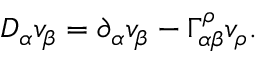<formula> <loc_0><loc_0><loc_500><loc_500>D _ { \alpha } v _ { \beta } = \partial _ { \alpha } v _ { \beta } - \Gamma _ { \alpha \beta } ^ { \rho } v _ { \rho } .</formula> 